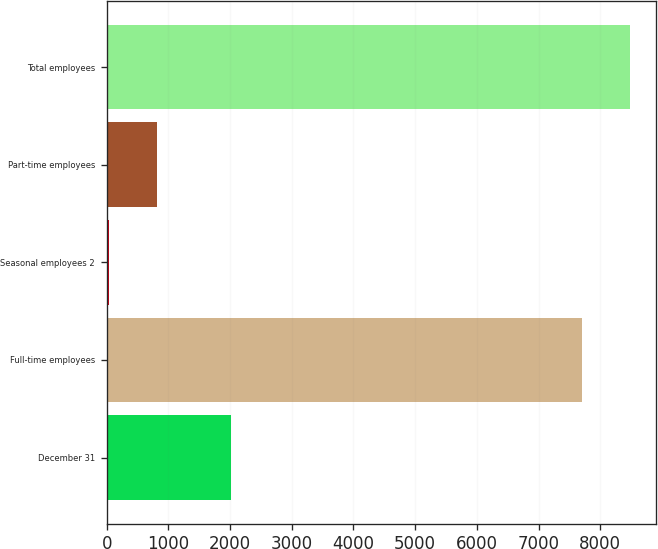Convert chart to OTSL. <chart><loc_0><loc_0><loc_500><loc_500><bar_chart><fcel>December 31<fcel>Full-time employees<fcel>Seasonal employees 2<fcel>Part-time employees<fcel>Total employees<nl><fcel>2015<fcel>7711<fcel>39<fcel>815.5<fcel>8487.5<nl></chart> 